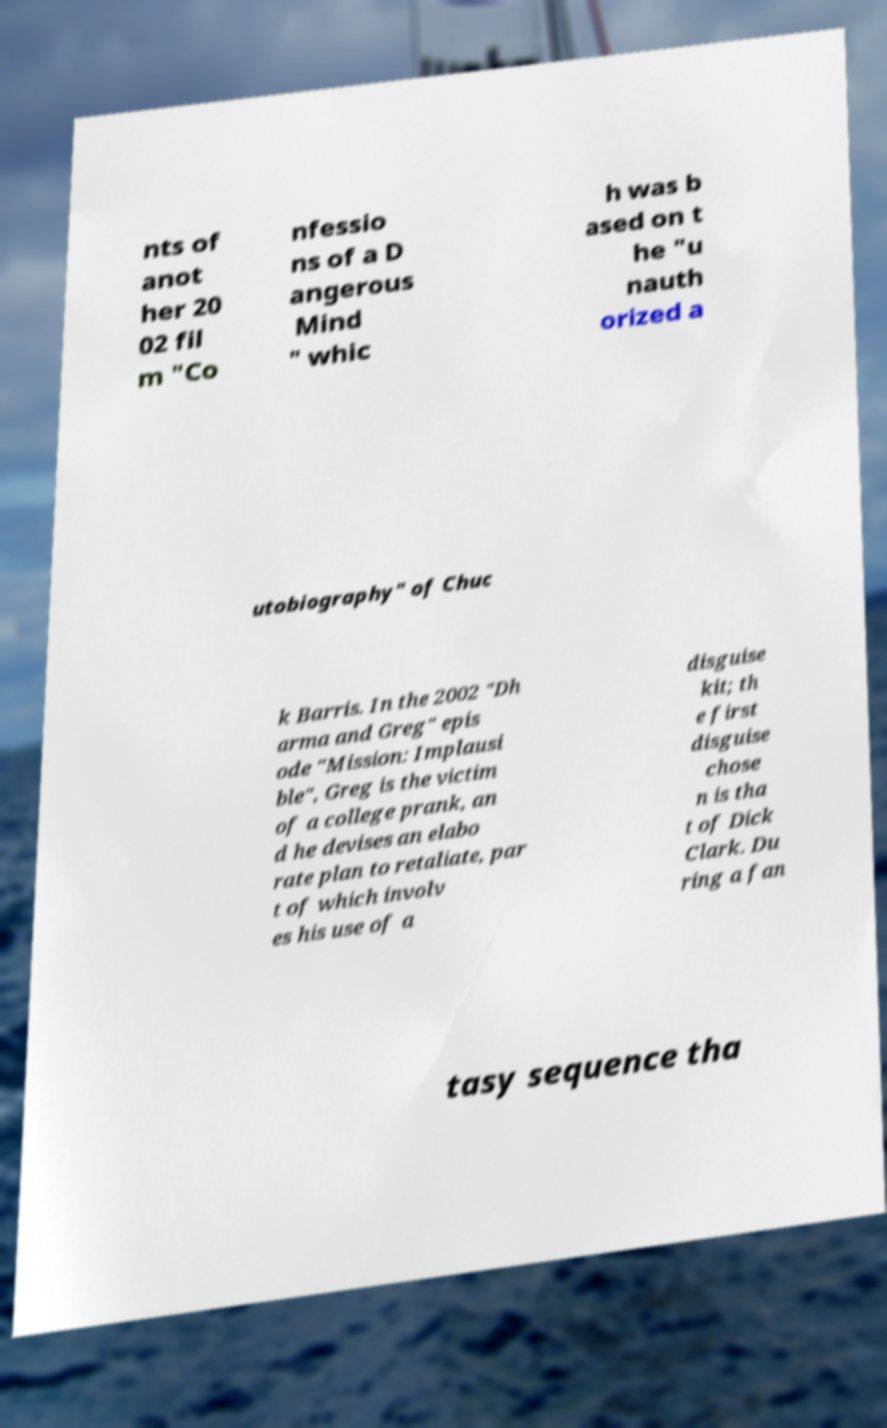There's text embedded in this image that I need extracted. Can you transcribe it verbatim? nts of anot her 20 02 fil m "Co nfessio ns of a D angerous Mind " whic h was b ased on t he "u nauth orized a utobiography" of Chuc k Barris. In the 2002 "Dh arma and Greg" epis ode "Mission: Implausi ble", Greg is the victim of a college prank, an d he devises an elabo rate plan to retaliate, par t of which involv es his use of a disguise kit; th e first disguise chose n is tha t of Dick Clark. Du ring a fan tasy sequence tha 